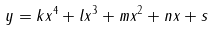Convert formula to latex. <formula><loc_0><loc_0><loc_500><loc_500>y = k x ^ { 4 } + l x ^ { 3 } + m x ^ { 2 } + n x + s</formula> 